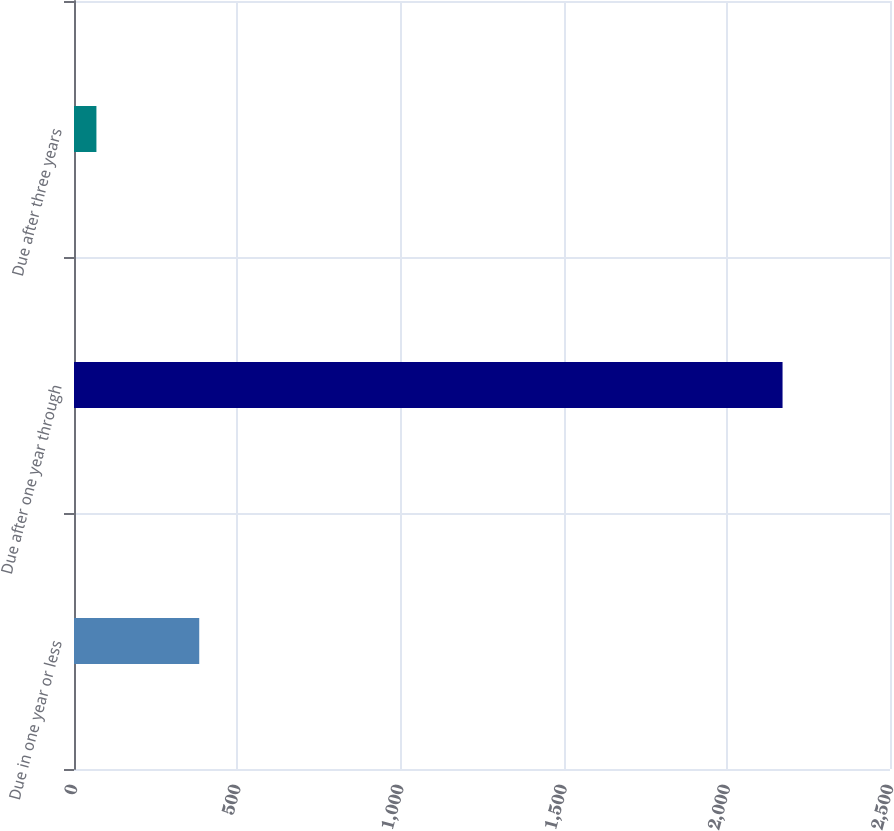Convert chart to OTSL. <chart><loc_0><loc_0><loc_500><loc_500><bar_chart><fcel>Due in one year or less<fcel>Due after one year through<fcel>Due after three years<nl><fcel>383.7<fcel>2170.8<fcel>68.7<nl></chart> 